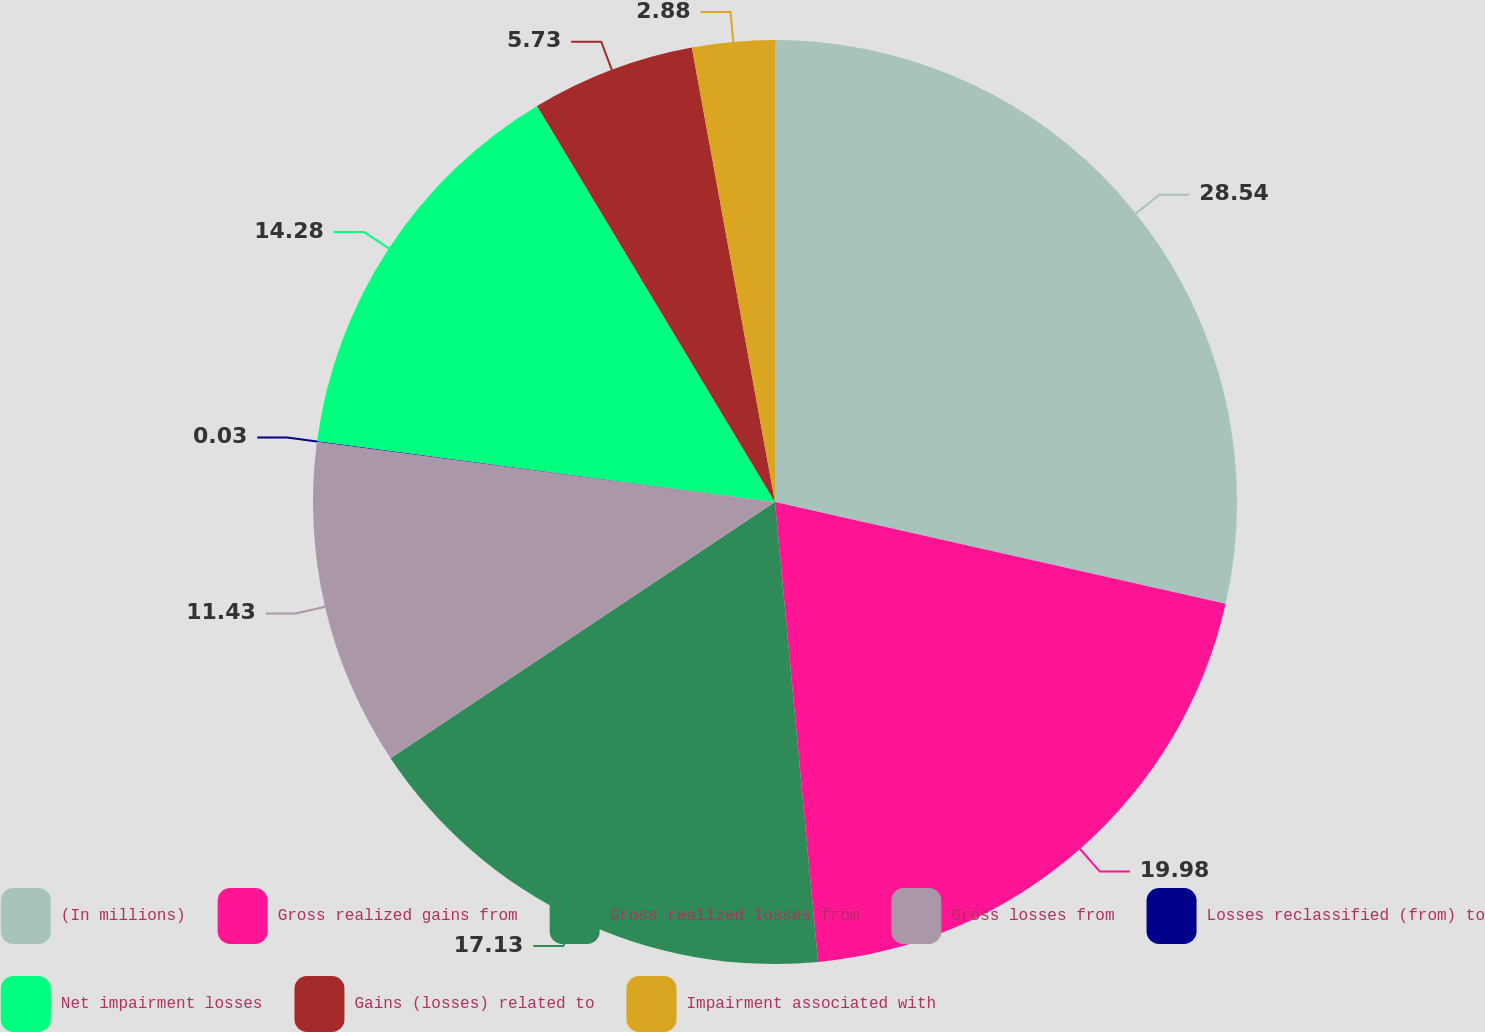Convert chart to OTSL. <chart><loc_0><loc_0><loc_500><loc_500><pie_chart><fcel>(In millions)<fcel>Gross realized gains from<fcel>Gross realized losses from<fcel>Gross losses from<fcel>Losses reclassified (from) to<fcel>Net impairment losses<fcel>Gains (losses) related to<fcel>Impairment associated with<nl><fcel>28.53%<fcel>19.98%<fcel>17.13%<fcel>11.43%<fcel>0.03%<fcel>14.28%<fcel>5.73%<fcel>2.88%<nl></chart> 